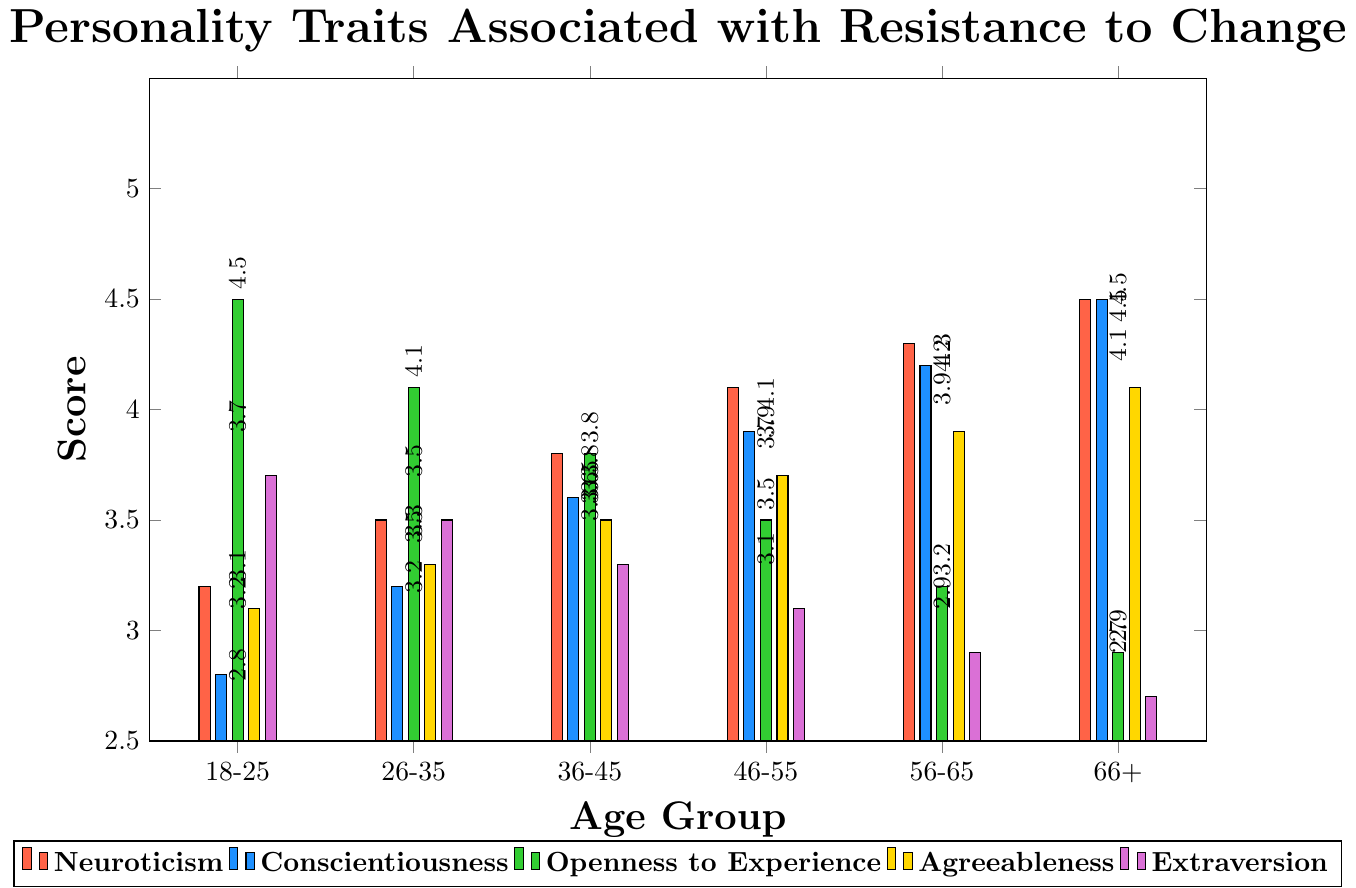What age group has the highest Neuroticism score? Neuroticism scores increase as age goes up. The highest score is for the age group 66+ with a score of 4.5.
Answer: 66+ Which age group has the lowest Conscientiousness score? Conscientiousness scores increase with age, with the lowest score of 2.8 for the age group 18-25.
Answer: 18-25 What is the difference in Extraversion scores between the age groups 18-25 and 66+? The Extraversion score for the age group 18-25 is 3.7, and for 66+ it is 2.7. The difference is calculated as 3.7 - 2.7 = 1.0.
Answer: 1.0 Which personality trait shows the most significant decrease in score as age increases from 18-25 to 66+? By comparing the differences in scores between the age group 18-25 and 66+, Openness to Experience shows the most significant decrease from 4.5 to 2.9, a difference of 1.6, which is the largest among the traits.
Answer: Openness to Experience For the age group 36-45, list the personality traits in descending order of scores. The scores for the age group 36-45 are Neuroticism: 3.8, Conscientiousness: 3.6, Openness to Experience: 3.8, Agreeableness: 3.5, Extraversion: 3.3. In descending order, they are: Neuroticism (3.8), Openness to Experience (3.8), Conscientiousness (3.6), Agreeableness (3.5), Extraversion (3.3).
Answer: Neuroticism, Openness to Experience, Conscientiousness, Agreeableness, Extraversion Between which age groups is the most significant increase in Agreeableness score observed? Agreeableness scores increase as age goes up. The most significant increase is between the age groups 18-25 and 66+ where the score rises from 3.1 to 4.1, a difference of 1.0.
Answer: 18-25 to 66+ Calculate the average Neuroticism score across all age groups. The Neuroticism scores are: 3.2, 3.5, 3.8, 4.1, 4.3, 4.5. The sum is 3.2 + 3.5 + 3.8 + 4.1 + 4.3 + 4.5 = 23.4. The average is 23.4 / 6 = 3.9.
Answer: 3.9 